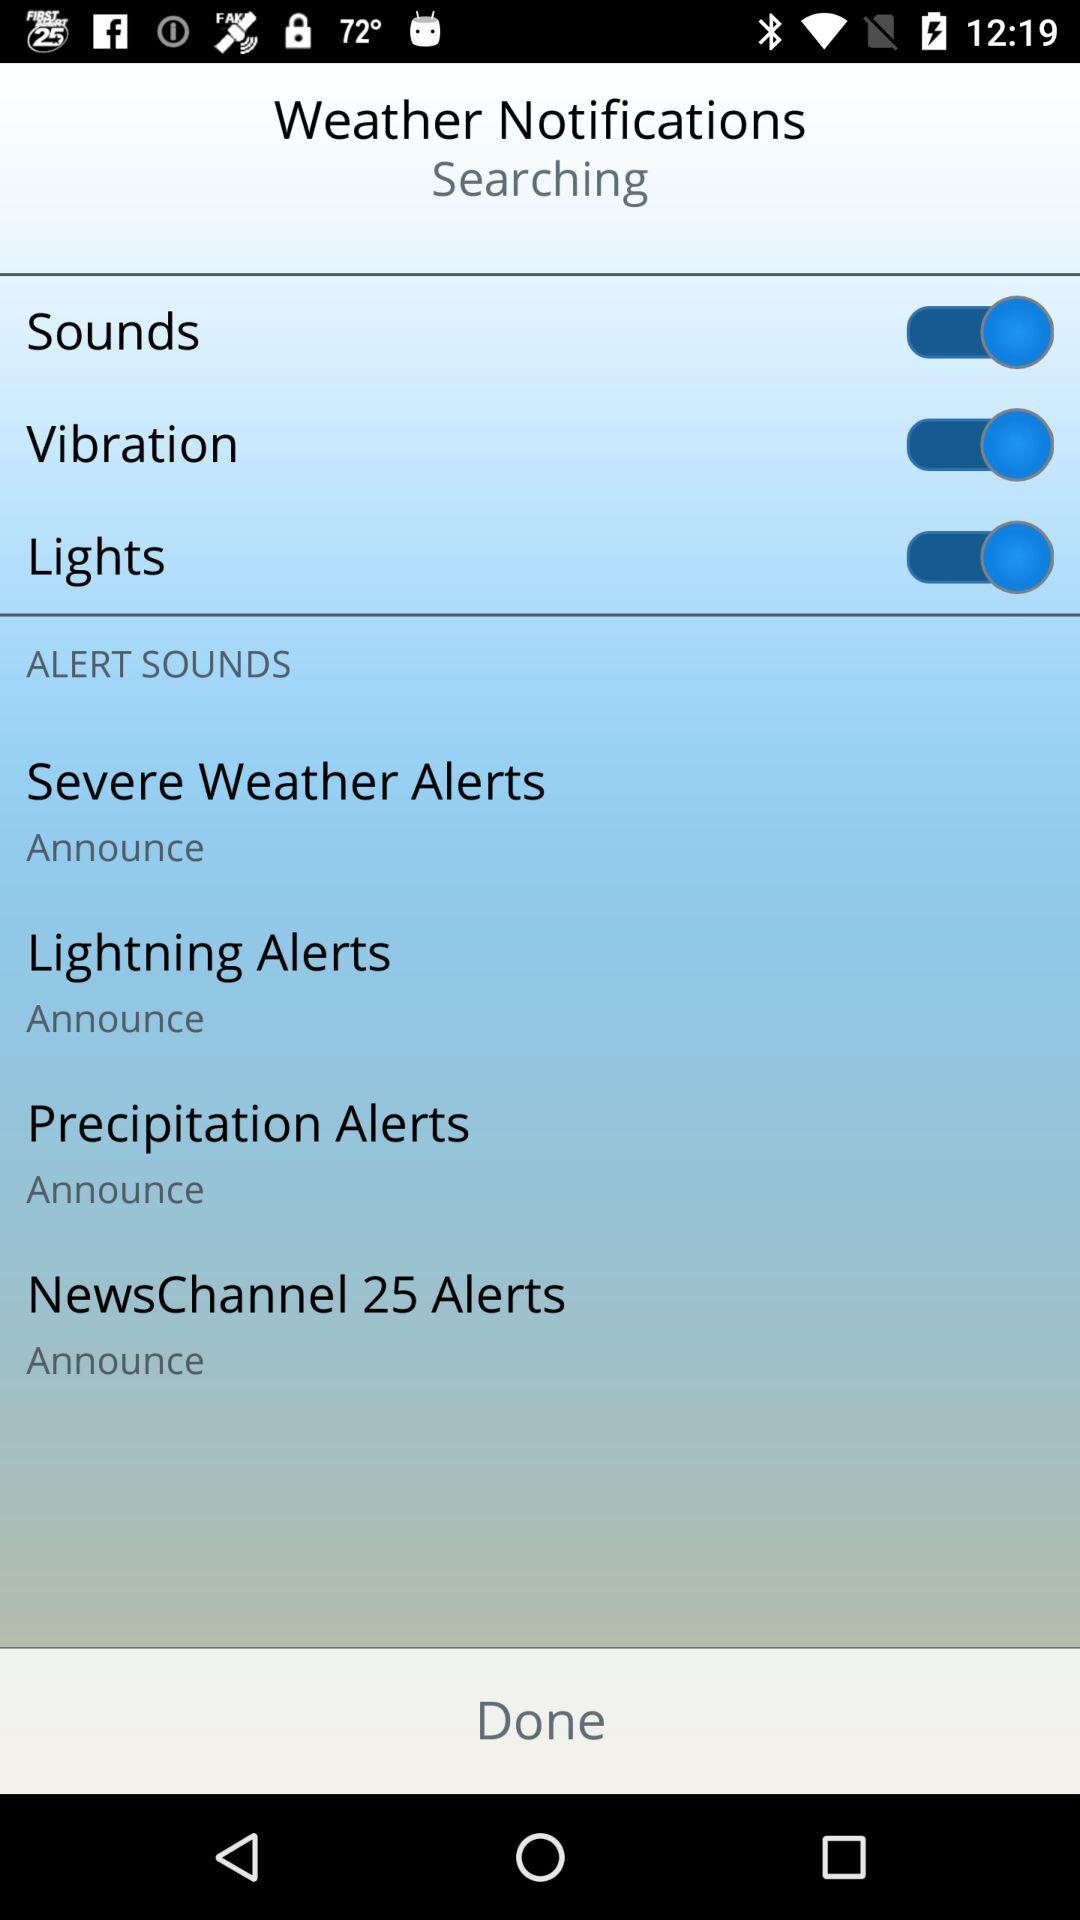What is the set alert sound for "Precipitation Alerts"? The set alert sound is "Announce". 